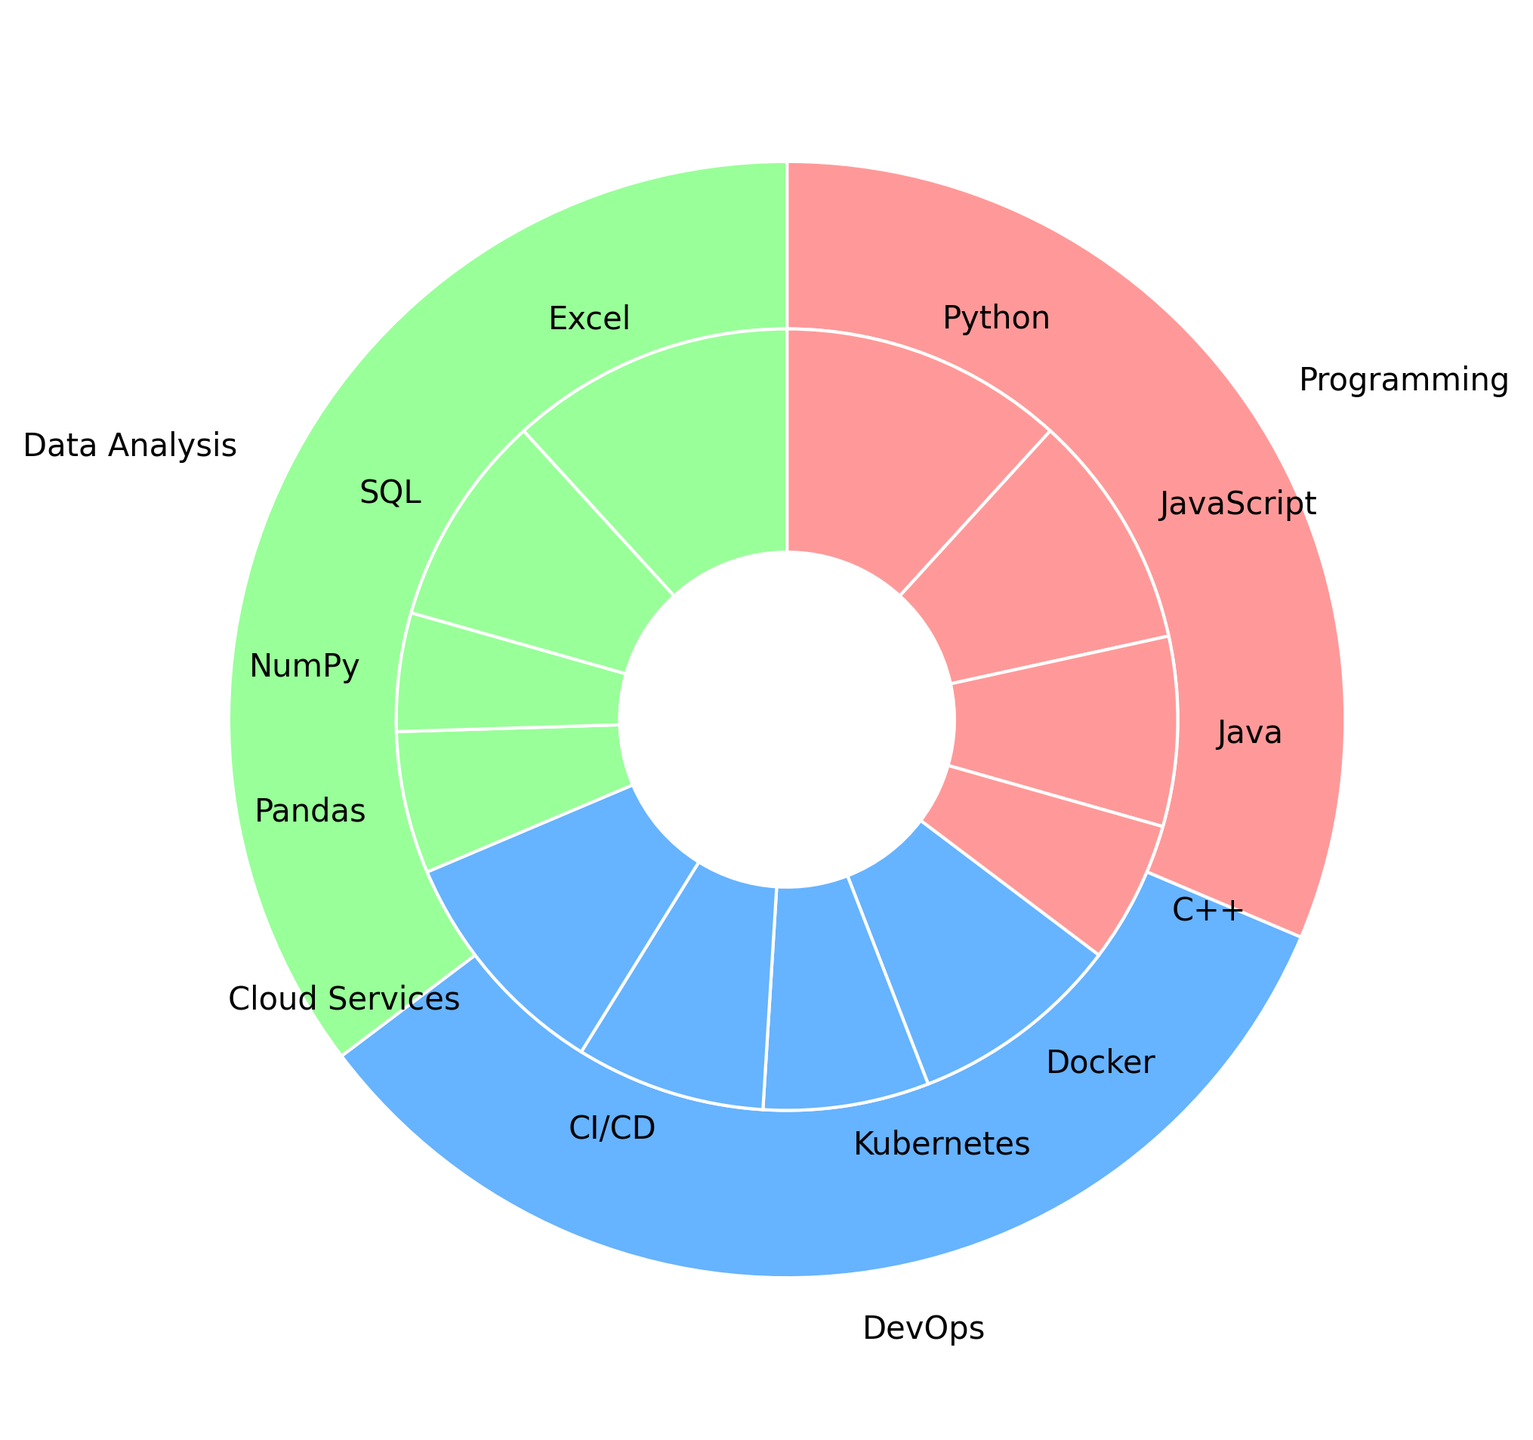What are the three most common skills among the employees in the startup? Looking at the inner pie chart representing individual skills, the three skills with the largest sections (proportions) are Python, Excel, and SQL.
Answer: Python, Excel, SQL Which skill category has the highest total employee count? The outer pie chart shows the total employee count per category. Programming appears to have the largest section, indicating it has the most employees.
Answer: Programming How many employees are proficient in DevOps-related skills? Summing up the employee counts in the inner pie chart for DevOps-related skills: Docker (9), Kubernetes (7), CI/CD (8), and Cloud Services (10) gives 9 + 7 + 8 + 10 = 34.
Answer: 34 Which category has the second most employees? By inspecting the outer pie chart, Programming has the highest count, while DevOps has the second-largest section.
Answer: DevOps How does the employee count of Python compare to JavaScript? In the inner pie chart, Python has a noticeably larger section than JavaScript. Python has 12 employees, whereas JavaScript has 10.
Answer: Python has more Which skill in Data Analysis has the least number of employees? Among the Data Analysis skills in the inner pie chart, NumPy has the smallest section, which means it has the fewest employees.
Answer: NumPy What is the ratio of employees skilled in Programming to those skilled in Data Analysis? Programming has a total of 36 employees (12 + 10 + 8 + 6), and Data Analysis has 32 (6 + 5 + 9 + 12). The ratio is 36 to 32, which simplifies to 9:8.
Answer: 9:8 Is there an equal number of employees skilled in Docker and in CI/CD? From the inner pie chart, both Docker and CI/CD have sections of the same size, indicating they both have 9 employees each.
Answer: Yes Which is larger, the total number of employees with Java knowledge or those with Kubernetes knowledge? The inner pie chart shows 8 employees for Java and 7 for Kubernetes. Therefore, the number of employees with Java knowledge is larger.
Answer: Java If we merge all skills in Programming and Data Analysis, what is the total number of employees? Summing the employee counts from Programming (12 + 10 + 8 + 6 = 36) and Data Analysis (6 + 5 + 9 + 12 = 32) yields 36 + 32 = 68.
Answer: 68 